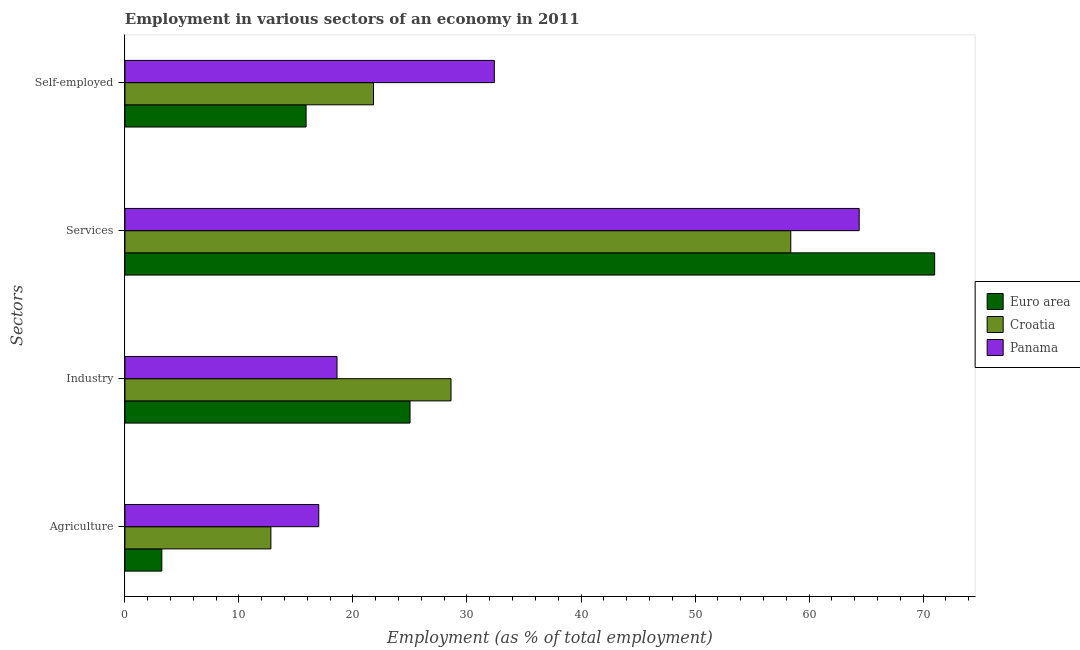How many different coloured bars are there?
Keep it short and to the point. 3. Are the number of bars on each tick of the Y-axis equal?
Make the answer very short. Yes. What is the label of the 3rd group of bars from the top?
Your response must be concise. Industry. What is the percentage of workers in services in Croatia?
Your answer should be very brief. 58.4. Across all countries, what is the minimum percentage of workers in agriculture?
Your response must be concise. 3.23. In which country was the percentage of self employed workers maximum?
Your answer should be compact. Panama. In which country was the percentage of workers in industry minimum?
Keep it short and to the point. Panama. What is the total percentage of workers in industry in the graph?
Offer a terse response. 72.2. What is the difference between the percentage of workers in agriculture in Croatia and that in Panama?
Your answer should be compact. -4.2. What is the difference between the percentage of workers in industry in Euro area and the percentage of workers in agriculture in Panama?
Keep it short and to the point. 8. What is the average percentage of self employed workers per country?
Ensure brevity in your answer.  23.36. What is the difference between the percentage of workers in agriculture and percentage of self employed workers in Euro area?
Offer a terse response. -12.65. In how many countries, is the percentage of workers in industry greater than 18 %?
Offer a terse response. 3. What is the ratio of the percentage of workers in services in Euro area to that in Panama?
Make the answer very short. 1.1. Is the percentage of workers in industry in Panama less than that in Croatia?
Offer a terse response. Yes. What is the difference between the highest and the second highest percentage of workers in agriculture?
Make the answer very short. 4.2. What is the difference between the highest and the lowest percentage of self employed workers?
Keep it short and to the point. 16.51. Is it the case that in every country, the sum of the percentage of workers in services and percentage of workers in industry is greater than the sum of percentage of workers in agriculture and percentage of self employed workers?
Offer a terse response. Yes. What does the 2nd bar from the top in Self-employed represents?
Keep it short and to the point. Croatia. Is it the case that in every country, the sum of the percentage of workers in agriculture and percentage of workers in industry is greater than the percentage of workers in services?
Provide a succinct answer. No. What is the difference between two consecutive major ticks on the X-axis?
Offer a very short reply. 10. Does the graph contain grids?
Offer a terse response. No. Where does the legend appear in the graph?
Provide a succinct answer. Center right. How are the legend labels stacked?
Provide a short and direct response. Vertical. What is the title of the graph?
Provide a short and direct response. Employment in various sectors of an economy in 2011. Does "Liberia" appear as one of the legend labels in the graph?
Give a very brief answer. No. What is the label or title of the X-axis?
Offer a very short reply. Employment (as % of total employment). What is the label or title of the Y-axis?
Your answer should be compact. Sectors. What is the Employment (as % of total employment) of Euro area in Agriculture?
Your answer should be compact. 3.23. What is the Employment (as % of total employment) of Croatia in Agriculture?
Your answer should be compact. 12.8. What is the Employment (as % of total employment) in Euro area in Industry?
Make the answer very short. 25. What is the Employment (as % of total employment) of Croatia in Industry?
Offer a terse response. 28.6. What is the Employment (as % of total employment) in Panama in Industry?
Offer a very short reply. 18.6. What is the Employment (as % of total employment) in Euro area in Services?
Keep it short and to the point. 71.02. What is the Employment (as % of total employment) in Croatia in Services?
Ensure brevity in your answer.  58.4. What is the Employment (as % of total employment) in Panama in Services?
Your answer should be very brief. 64.4. What is the Employment (as % of total employment) in Euro area in Self-employed?
Give a very brief answer. 15.89. What is the Employment (as % of total employment) in Croatia in Self-employed?
Provide a succinct answer. 21.8. What is the Employment (as % of total employment) in Panama in Self-employed?
Offer a terse response. 32.4. Across all Sectors, what is the maximum Employment (as % of total employment) of Euro area?
Your response must be concise. 71.02. Across all Sectors, what is the maximum Employment (as % of total employment) of Croatia?
Offer a very short reply. 58.4. Across all Sectors, what is the maximum Employment (as % of total employment) of Panama?
Your answer should be very brief. 64.4. Across all Sectors, what is the minimum Employment (as % of total employment) in Euro area?
Offer a very short reply. 3.23. Across all Sectors, what is the minimum Employment (as % of total employment) in Croatia?
Provide a succinct answer. 12.8. Across all Sectors, what is the minimum Employment (as % of total employment) of Panama?
Provide a short and direct response. 17. What is the total Employment (as % of total employment) in Euro area in the graph?
Ensure brevity in your answer.  115.15. What is the total Employment (as % of total employment) in Croatia in the graph?
Give a very brief answer. 121.6. What is the total Employment (as % of total employment) in Panama in the graph?
Offer a terse response. 132.4. What is the difference between the Employment (as % of total employment) in Euro area in Agriculture and that in Industry?
Provide a short and direct response. -21.77. What is the difference between the Employment (as % of total employment) of Croatia in Agriculture and that in Industry?
Provide a short and direct response. -15.8. What is the difference between the Employment (as % of total employment) of Panama in Agriculture and that in Industry?
Ensure brevity in your answer.  -1.6. What is the difference between the Employment (as % of total employment) in Euro area in Agriculture and that in Services?
Make the answer very short. -67.79. What is the difference between the Employment (as % of total employment) in Croatia in Agriculture and that in Services?
Ensure brevity in your answer.  -45.6. What is the difference between the Employment (as % of total employment) in Panama in Agriculture and that in Services?
Provide a succinct answer. -47.4. What is the difference between the Employment (as % of total employment) in Euro area in Agriculture and that in Self-employed?
Provide a succinct answer. -12.65. What is the difference between the Employment (as % of total employment) of Panama in Agriculture and that in Self-employed?
Give a very brief answer. -15.4. What is the difference between the Employment (as % of total employment) in Euro area in Industry and that in Services?
Offer a very short reply. -46.02. What is the difference between the Employment (as % of total employment) in Croatia in Industry and that in Services?
Keep it short and to the point. -29.8. What is the difference between the Employment (as % of total employment) in Panama in Industry and that in Services?
Ensure brevity in your answer.  -45.8. What is the difference between the Employment (as % of total employment) of Euro area in Industry and that in Self-employed?
Ensure brevity in your answer.  9.12. What is the difference between the Employment (as % of total employment) of Euro area in Services and that in Self-employed?
Provide a short and direct response. 55.13. What is the difference between the Employment (as % of total employment) in Croatia in Services and that in Self-employed?
Provide a short and direct response. 36.6. What is the difference between the Employment (as % of total employment) in Euro area in Agriculture and the Employment (as % of total employment) in Croatia in Industry?
Offer a terse response. -25.37. What is the difference between the Employment (as % of total employment) of Euro area in Agriculture and the Employment (as % of total employment) of Panama in Industry?
Make the answer very short. -15.37. What is the difference between the Employment (as % of total employment) in Croatia in Agriculture and the Employment (as % of total employment) in Panama in Industry?
Your answer should be very brief. -5.8. What is the difference between the Employment (as % of total employment) in Euro area in Agriculture and the Employment (as % of total employment) in Croatia in Services?
Keep it short and to the point. -55.17. What is the difference between the Employment (as % of total employment) in Euro area in Agriculture and the Employment (as % of total employment) in Panama in Services?
Make the answer very short. -61.17. What is the difference between the Employment (as % of total employment) of Croatia in Agriculture and the Employment (as % of total employment) of Panama in Services?
Your answer should be very brief. -51.6. What is the difference between the Employment (as % of total employment) of Euro area in Agriculture and the Employment (as % of total employment) of Croatia in Self-employed?
Your answer should be compact. -18.57. What is the difference between the Employment (as % of total employment) of Euro area in Agriculture and the Employment (as % of total employment) of Panama in Self-employed?
Ensure brevity in your answer.  -29.17. What is the difference between the Employment (as % of total employment) in Croatia in Agriculture and the Employment (as % of total employment) in Panama in Self-employed?
Ensure brevity in your answer.  -19.6. What is the difference between the Employment (as % of total employment) of Euro area in Industry and the Employment (as % of total employment) of Croatia in Services?
Provide a short and direct response. -33.4. What is the difference between the Employment (as % of total employment) in Euro area in Industry and the Employment (as % of total employment) in Panama in Services?
Offer a very short reply. -39.4. What is the difference between the Employment (as % of total employment) of Croatia in Industry and the Employment (as % of total employment) of Panama in Services?
Ensure brevity in your answer.  -35.8. What is the difference between the Employment (as % of total employment) in Euro area in Industry and the Employment (as % of total employment) in Croatia in Self-employed?
Keep it short and to the point. 3.2. What is the difference between the Employment (as % of total employment) in Euro area in Industry and the Employment (as % of total employment) in Panama in Self-employed?
Keep it short and to the point. -7.4. What is the difference between the Employment (as % of total employment) of Euro area in Services and the Employment (as % of total employment) of Croatia in Self-employed?
Provide a short and direct response. 49.22. What is the difference between the Employment (as % of total employment) in Euro area in Services and the Employment (as % of total employment) in Panama in Self-employed?
Keep it short and to the point. 38.62. What is the difference between the Employment (as % of total employment) in Croatia in Services and the Employment (as % of total employment) in Panama in Self-employed?
Offer a terse response. 26. What is the average Employment (as % of total employment) of Euro area per Sectors?
Your answer should be compact. 28.79. What is the average Employment (as % of total employment) in Croatia per Sectors?
Give a very brief answer. 30.4. What is the average Employment (as % of total employment) of Panama per Sectors?
Your answer should be compact. 33.1. What is the difference between the Employment (as % of total employment) in Euro area and Employment (as % of total employment) in Croatia in Agriculture?
Give a very brief answer. -9.57. What is the difference between the Employment (as % of total employment) of Euro area and Employment (as % of total employment) of Panama in Agriculture?
Offer a terse response. -13.77. What is the difference between the Employment (as % of total employment) of Croatia and Employment (as % of total employment) of Panama in Agriculture?
Provide a short and direct response. -4.2. What is the difference between the Employment (as % of total employment) of Euro area and Employment (as % of total employment) of Croatia in Industry?
Offer a very short reply. -3.6. What is the difference between the Employment (as % of total employment) in Euro area and Employment (as % of total employment) in Panama in Industry?
Offer a very short reply. 6.4. What is the difference between the Employment (as % of total employment) of Croatia and Employment (as % of total employment) of Panama in Industry?
Keep it short and to the point. 10. What is the difference between the Employment (as % of total employment) of Euro area and Employment (as % of total employment) of Croatia in Services?
Provide a succinct answer. 12.62. What is the difference between the Employment (as % of total employment) of Euro area and Employment (as % of total employment) of Panama in Services?
Provide a short and direct response. 6.62. What is the difference between the Employment (as % of total employment) in Croatia and Employment (as % of total employment) in Panama in Services?
Your answer should be compact. -6. What is the difference between the Employment (as % of total employment) of Euro area and Employment (as % of total employment) of Croatia in Self-employed?
Offer a terse response. -5.91. What is the difference between the Employment (as % of total employment) of Euro area and Employment (as % of total employment) of Panama in Self-employed?
Offer a very short reply. -16.51. What is the difference between the Employment (as % of total employment) of Croatia and Employment (as % of total employment) of Panama in Self-employed?
Your response must be concise. -10.6. What is the ratio of the Employment (as % of total employment) of Euro area in Agriculture to that in Industry?
Provide a succinct answer. 0.13. What is the ratio of the Employment (as % of total employment) of Croatia in Agriculture to that in Industry?
Make the answer very short. 0.45. What is the ratio of the Employment (as % of total employment) of Panama in Agriculture to that in Industry?
Provide a succinct answer. 0.91. What is the ratio of the Employment (as % of total employment) in Euro area in Agriculture to that in Services?
Provide a short and direct response. 0.05. What is the ratio of the Employment (as % of total employment) in Croatia in Agriculture to that in Services?
Your answer should be very brief. 0.22. What is the ratio of the Employment (as % of total employment) in Panama in Agriculture to that in Services?
Offer a terse response. 0.26. What is the ratio of the Employment (as % of total employment) of Euro area in Agriculture to that in Self-employed?
Offer a very short reply. 0.2. What is the ratio of the Employment (as % of total employment) in Croatia in Agriculture to that in Self-employed?
Your response must be concise. 0.59. What is the ratio of the Employment (as % of total employment) of Panama in Agriculture to that in Self-employed?
Provide a short and direct response. 0.52. What is the ratio of the Employment (as % of total employment) of Euro area in Industry to that in Services?
Make the answer very short. 0.35. What is the ratio of the Employment (as % of total employment) in Croatia in Industry to that in Services?
Keep it short and to the point. 0.49. What is the ratio of the Employment (as % of total employment) of Panama in Industry to that in Services?
Your answer should be very brief. 0.29. What is the ratio of the Employment (as % of total employment) of Euro area in Industry to that in Self-employed?
Your response must be concise. 1.57. What is the ratio of the Employment (as % of total employment) of Croatia in Industry to that in Self-employed?
Your answer should be very brief. 1.31. What is the ratio of the Employment (as % of total employment) of Panama in Industry to that in Self-employed?
Provide a succinct answer. 0.57. What is the ratio of the Employment (as % of total employment) of Euro area in Services to that in Self-employed?
Your answer should be very brief. 4.47. What is the ratio of the Employment (as % of total employment) of Croatia in Services to that in Self-employed?
Provide a short and direct response. 2.68. What is the ratio of the Employment (as % of total employment) in Panama in Services to that in Self-employed?
Your answer should be compact. 1.99. What is the difference between the highest and the second highest Employment (as % of total employment) in Euro area?
Offer a terse response. 46.02. What is the difference between the highest and the second highest Employment (as % of total employment) in Croatia?
Offer a very short reply. 29.8. What is the difference between the highest and the lowest Employment (as % of total employment) in Euro area?
Make the answer very short. 67.79. What is the difference between the highest and the lowest Employment (as % of total employment) in Croatia?
Ensure brevity in your answer.  45.6. What is the difference between the highest and the lowest Employment (as % of total employment) of Panama?
Your answer should be very brief. 47.4. 